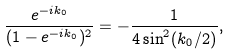Convert formula to latex. <formula><loc_0><loc_0><loc_500><loc_500>\frac { e ^ { - i k _ { 0 } } } { ( 1 - e ^ { - i k _ { 0 } } ) ^ { 2 } } = - \frac { 1 } { 4 \sin ^ { 2 } ( k _ { 0 } / 2 ) } ,</formula> 